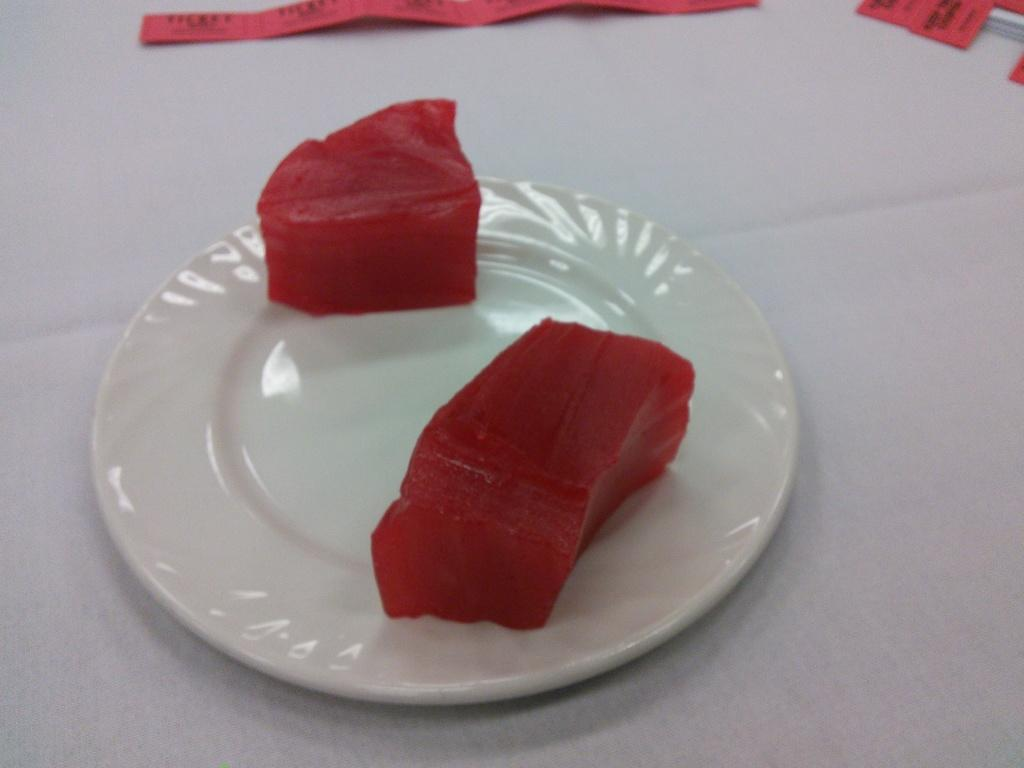What is on the plate that is visible in the image? There is a plate with food in the image. Besides the plate of food, what other items can be seen in the image? There are papers on the surface in the image. What is the color of the surface in the image? The surface is white in color. What type of humor can be seen in the image? There is no humor present in the image; it features a plate with food and papers on a white surface. What button is visible on the plate in the image? There is no button visible on the plate or any other part of the image. 